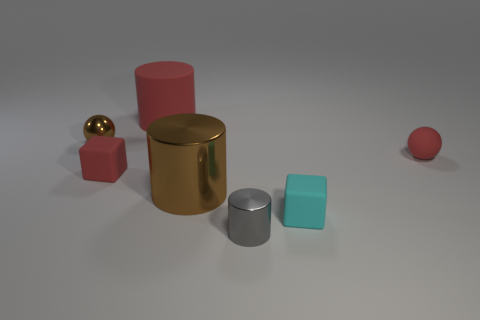There is a small cube that is the same color as the rubber cylinder; what is its material?
Your response must be concise. Rubber. Does the matte sphere have the same size as the brown shiny cylinder?
Offer a very short reply. No. There is a shiny cylinder on the right side of the large brown metal object; is there a tiny thing on the right side of it?
Your answer should be very brief. Yes. There is a matte cylinder that is the same color as the small matte ball; what size is it?
Keep it short and to the point. Large. What is the shape of the small red object that is on the left side of the big red thing?
Offer a very short reply. Cube. There is a cube left of the red thing behind the small brown metallic object; what number of cylinders are behind it?
Offer a very short reply. 1. There is a red rubber sphere; does it have the same size as the cube that is right of the red cube?
Give a very brief answer. Yes. What size is the red object behind the red thing that is on the right side of the rubber cylinder?
Your answer should be compact. Large. How many small objects have the same material as the red block?
Keep it short and to the point. 2. Is there a gray matte cylinder?
Your response must be concise. No. 